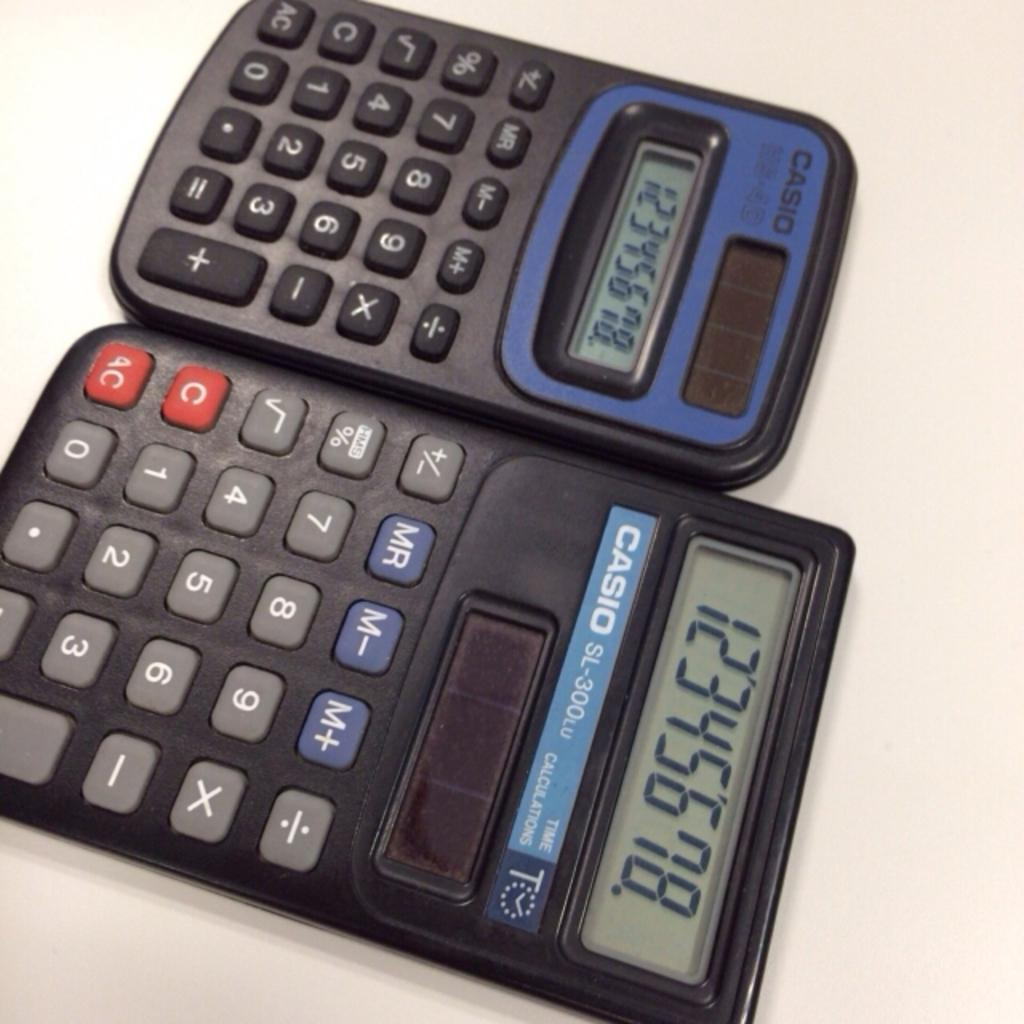<image>
Write a terse but informative summary of the picture. Two Casio calculators placed right next to each other. 